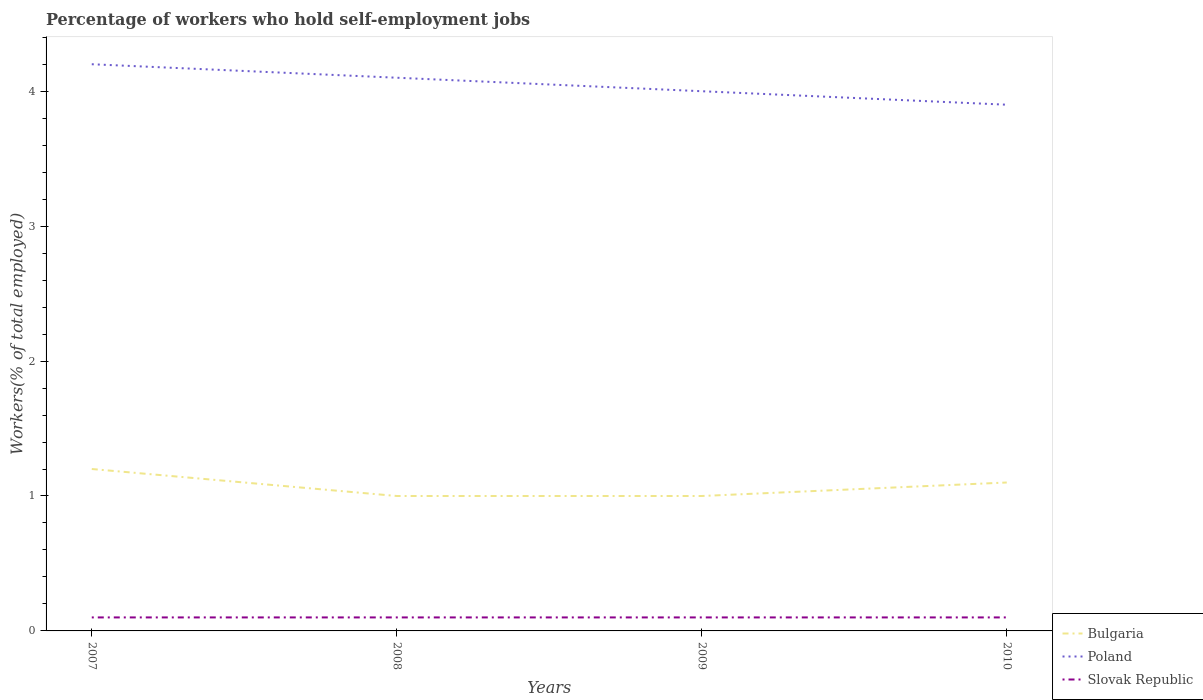What is the total percentage of self-employed workers in Bulgaria in the graph?
Provide a short and direct response. -0.1. What is the difference between the highest and the second highest percentage of self-employed workers in Poland?
Give a very brief answer. 0.3. Is the percentage of self-employed workers in Slovak Republic strictly greater than the percentage of self-employed workers in Poland over the years?
Provide a succinct answer. Yes. How many lines are there?
Provide a succinct answer. 3. What is the difference between two consecutive major ticks on the Y-axis?
Offer a terse response. 1. Are the values on the major ticks of Y-axis written in scientific E-notation?
Your response must be concise. No. Does the graph contain any zero values?
Offer a very short reply. No. Does the graph contain grids?
Make the answer very short. No. Where does the legend appear in the graph?
Provide a succinct answer. Bottom right. How many legend labels are there?
Your response must be concise. 3. What is the title of the graph?
Make the answer very short. Percentage of workers who hold self-employment jobs. What is the label or title of the Y-axis?
Provide a succinct answer. Workers(% of total employed). What is the Workers(% of total employed) in Bulgaria in 2007?
Provide a succinct answer. 1.2. What is the Workers(% of total employed) in Poland in 2007?
Offer a very short reply. 4.2. What is the Workers(% of total employed) of Slovak Republic in 2007?
Offer a very short reply. 0.1. What is the Workers(% of total employed) in Bulgaria in 2008?
Your answer should be compact. 1. What is the Workers(% of total employed) of Poland in 2008?
Provide a short and direct response. 4.1. What is the Workers(% of total employed) of Slovak Republic in 2008?
Offer a very short reply. 0.1. What is the Workers(% of total employed) in Bulgaria in 2009?
Keep it short and to the point. 1. What is the Workers(% of total employed) in Poland in 2009?
Your answer should be compact. 4. What is the Workers(% of total employed) in Slovak Republic in 2009?
Keep it short and to the point. 0.1. What is the Workers(% of total employed) in Bulgaria in 2010?
Your answer should be very brief. 1.1. What is the Workers(% of total employed) of Poland in 2010?
Make the answer very short. 3.9. What is the Workers(% of total employed) of Slovak Republic in 2010?
Give a very brief answer. 0.1. Across all years, what is the maximum Workers(% of total employed) in Bulgaria?
Your answer should be compact. 1.2. Across all years, what is the maximum Workers(% of total employed) of Poland?
Ensure brevity in your answer.  4.2. Across all years, what is the maximum Workers(% of total employed) in Slovak Republic?
Your answer should be very brief. 0.1. Across all years, what is the minimum Workers(% of total employed) in Bulgaria?
Offer a terse response. 1. Across all years, what is the minimum Workers(% of total employed) of Poland?
Ensure brevity in your answer.  3.9. Across all years, what is the minimum Workers(% of total employed) in Slovak Republic?
Your answer should be compact. 0.1. What is the total Workers(% of total employed) of Poland in the graph?
Offer a terse response. 16.2. What is the difference between the Workers(% of total employed) in Slovak Republic in 2007 and that in 2008?
Your response must be concise. 0. What is the difference between the Workers(% of total employed) of Poland in 2007 and that in 2010?
Offer a terse response. 0.3. What is the difference between the Workers(% of total employed) in Bulgaria in 2008 and that in 2009?
Offer a terse response. 0. What is the difference between the Workers(% of total employed) in Slovak Republic in 2008 and that in 2009?
Make the answer very short. 0. What is the difference between the Workers(% of total employed) in Poland in 2008 and that in 2010?
Offer a terse response. 0.2. What is the difference between the Workers(% of total employed) in Slovak Republic in 2008 and that in 2010?
Your answer should be very brief. 0. What is the difference between the Workers(% of total employed) in Bulgaria in 2007 and the Workers(% of total employed) in Poland in 2008?
Your answer should be compact. -2.9. What is the difference between the Workers(% of total employed) of Bulgaria in 2007 and the Workers(% of total employed) of Slovak Republic in 2008?
Your response must be concise. 1.1. What is the difference between the Workers(% of total employed) in Poland in 2007 and the Workers(% of total employed) in Slovak Republic in 2008?
Make the answer very short. 4.1. What is the difference between the Workers(% of total employed) in Bulgaria in 2007 and the Workers(% of total employed) in Poland in 2009?
Provide a short and direct response. -2.8. What is the difference between the Workers(% of total employed) of Bulgaria in 2007 and the Workers(% of total employed) of Slovak Republic in 2010?
Give a very brief answer. 1.1. What is the difference between the Workers(% of total employed) of Poland in 2007 and the Workers(% of total employed) of Slovak Republic in 2010?
Keep it short and to the point. 4.1. What is the difference between the Workers(% of total employed) in Poland in 2008 and the Workers(% of total employed) in Slovak Republic in 2009?
Offer a very short reply. 4. What is the difference between the Workers(% of total employed) of Bulgaria in 2008 and the Workers(% of total employed) of Poland in 2010?
Your answer should be compact. -2.9. What is the difference between the Workers(% of total employed) in Bulgaria in 2008 and the Workers(% of total employed) in Slovak Republic in 2010?
Your answer should be compact. 0.9. What is the average Workers(% of total employed) of Bulgaria per year?
Offer a very short reply. 1.07. What is the average Workers(% of total employed) in Poland per year?
Make the answer very short. 4.05. What is the average Workers(% of total employed) of Slovak Republic per year?
Provide a succinct answer. 0.1. In the year 2007, what is the difference between the Workers(% of total employed) in Bulgaria and Workers(% of total employed) in Poland?
Your answer should be compact. -3. In the year 2007, what is the difference between the Workers(% of total employed) in Poland and Workers(% of total employed) in Slovak Republic?
Your response must be concise. 4.1. In the year 2008, what is the difference between the Workers(% of total employed) of Poland and Workers(% of total employed) of Slovak Republic?
Your answer should be compact. 4. In the year 2009, what is the difference between the Workers(% of total employed) in Bulgaria and Workers(% of total employed) in Slovak Republic?
Provide a short and direct response. 0.9. In the year 2010, what is the difference between the Workers(% of total employed) of Bulgaria and Workers(% of total employed) of Slovak Republic?
Give a very brief answer. 1. What is the ratio of the Workers(% of total employed) of Poland in 2007 to that in 2008?
Ensure brevity in your answer.  1.02. What is the ratio of the Workers(% of total employed) in Bulgaria in 2007 to that in 2009?
Your answer should be compact. 1.2. What is the ratio of the Workers(% of total employed) in Slovak Republic in 2007 to that in 2009?
Ensure brevity in your answer.  1. What is the ratio of the Workers(% of total employed) of Bulgaria in 2007 to that in 2010?
Offer a very short reply. 1.09. What is the ratio of the Workers(% of total employed) in Poland in 2007 to that in 2010?
Ensure brevity in your answer.  1.08. What is the ratio of the Workers(% of total employed) in Slovak Republic in 2007 to that in 2010?
Provide a succinct answer. 1. What is the ratio of the Workers(% of total employed) in Bulgaria in 2008 to that in 2009?
Provide a short and direct response. 1. What is the ratio of the Workers(% of total employed) of Poland in 2008 to that in 2009?
Make the answer very short. 1.02. What is the ratio of the Workers(% of total employed) in Poland in 2008 to that in 2010?
Your response must be concise. 1.05. What is the ratio of the Workers(% of total employed) of Slovak Republic in 2008 to that in 2010?
Your answer should be very brief. 1. What is the ratio of the Workers(% of total employed) in Bulgaria in 2009 to that in 2010?
Your answer should be very brief. 0.91. What is the ratio of the Workers(% of total employed) of Poland in 2009 to that in 2010?
Your answer should be compact. 1.03. What is the ratio of the Workers(% of total employed) of Slovak Republic in 2009 to that in 2010?
Provide a succinct answer. 1. What is the difference between the highest and the second highest Workers(% of total employed) of Bulgaria?
Your response must be concise. 0.1. What is the difference between the highest and the lowest Workers(% of total employed) in Bulgaria?
Your answer should be very brief. 0.2. What is the difference between the highest and the lowest Workers(% of total employed) in Slovak Republic?
Provide a short and direct response. 0. 